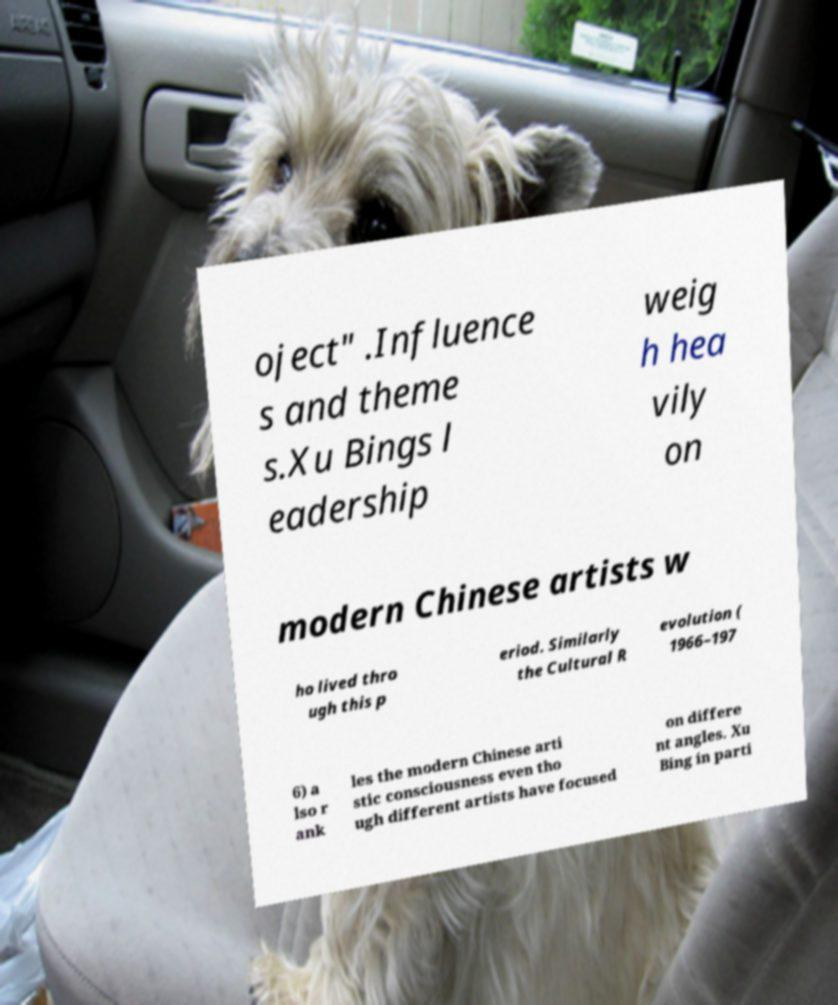Please identify and transcribe the text found in this image. oject" .Influence s and theme s.Xu Bings l eadership weig h hea vily on modern Chinese artists w ho lived thro ugh this p eriod. Similarly the Cultural R evolution ( 1966–197 6) a lso r ank les the modern Chinese arti stic consciousness even tho ugh different artists have focused on differe nt angles. Xu Bing in parti 